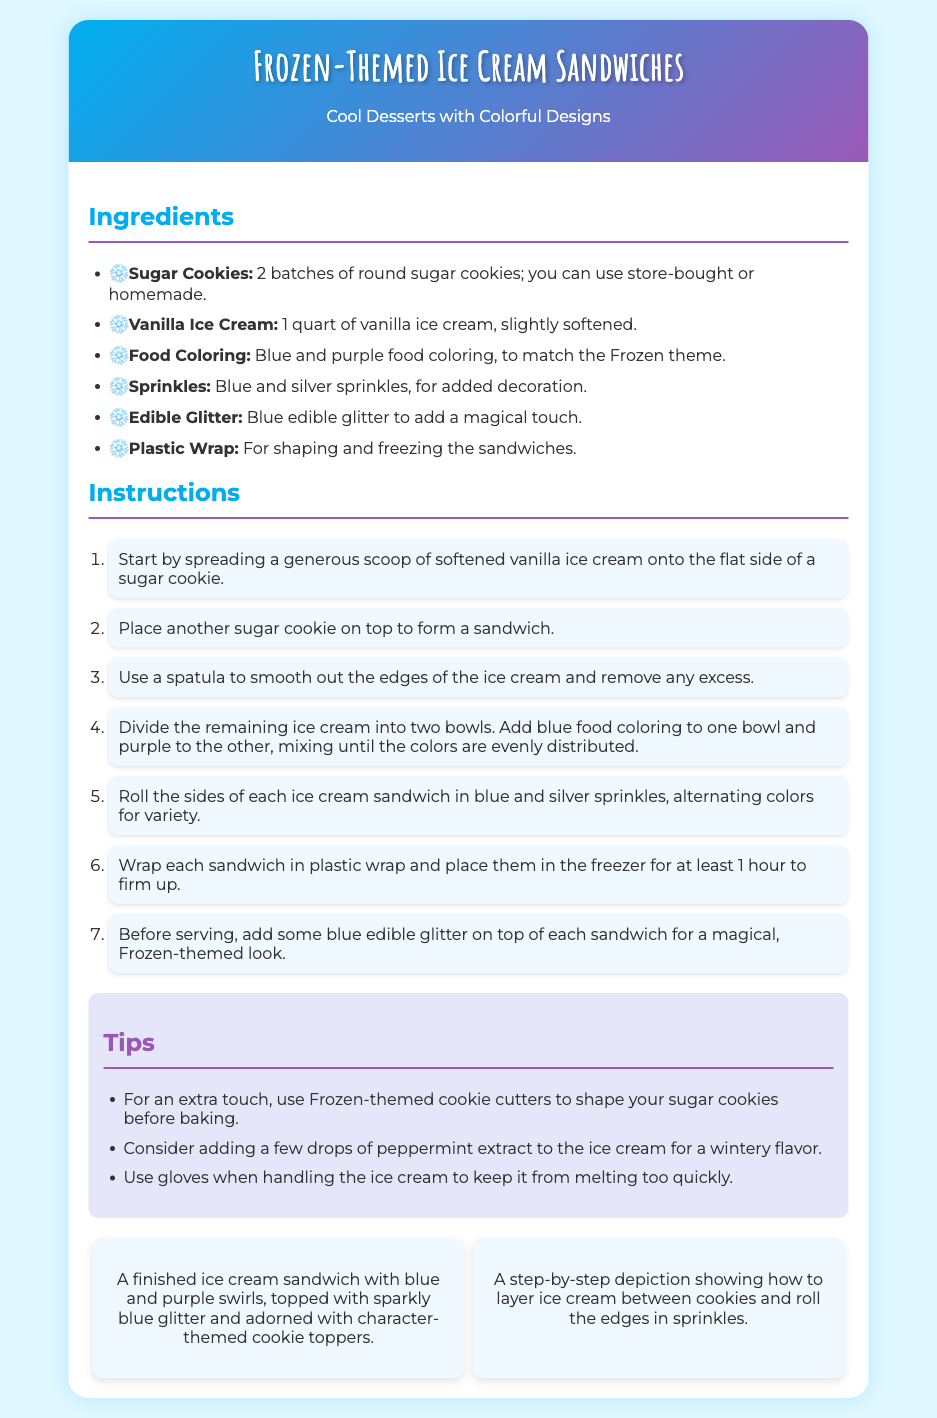What are the main colors used in the food coloring? The document lists blue and purple as the colors used in food coloring.
Answer: Blue and purple How many batches of sugar cookies are needed? The recipe specifies that 2 batches of round sugar cookies are needed, either store-bought or homemade.
Answer: 2 batches What is the total amount of vanilla ice cream required? The recipe mentions needing 1 quart of vanilla ice cream, slightly softened.
Answer: 1 quart What should you do with excess ice cream after forming the sandwiches? The instructions indicate to smooth out the edges of the ice cream and remove any excess after forming the sandwiches.
Answer: Remove excess How long should the ice cream sandwiches be frozen? The instructions state to freeze the sandwiches for at least 1 hour to firm up.
Answer: 1 hour What unique touch can be added using cookie cutters? The recipe suggests using Frozen-themed cookie cutters to shape the sugar cookies before baking.
Answer: Frozen-themed cookie cutters What additional flavor can be added to the ice cream? The tips recommend adding a few drops of peppermint extract for a wintery flavor.
Answer: Peppermint extract What are the two types of sprinkles used? The ingredients list blue and silver sprinkles for decoration on the ice cream sandwiches.
Answer: Blue and silver What type of visual is depicted showing the layering process? The visuals include a step-by-step depiction of how to layer ice cream between cookies.
Answer: Step-by-step depiction 